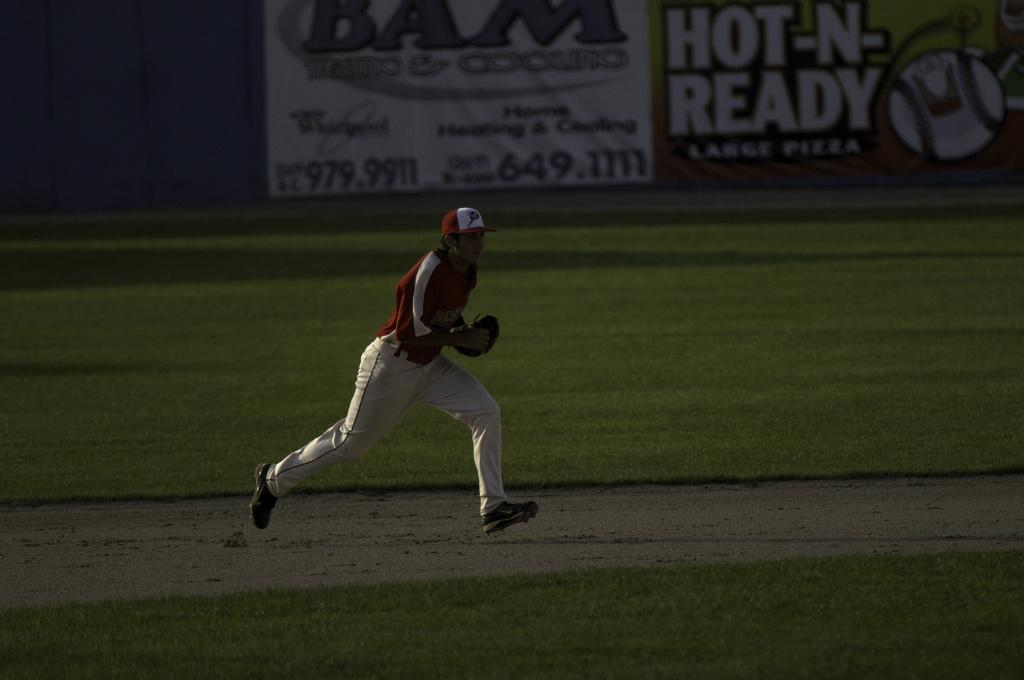Who is the main subject in the image? There is a man in the center of the image. What is the man doing in the image? The man appears to be running. What type of environment is visible in the image? There is grassland in the image. What else can be seen in the image besides the man and the grassland? There are posters in the image. What type of reaction can be seen from the man when the earthquake occurs in the image? There is no earthquake present in the image, and therefore no reaction from the man can be observed. What type of shoe is the man wearing in the image? The image does not provide enough detail to determine the type of shoe the man is wearing. 